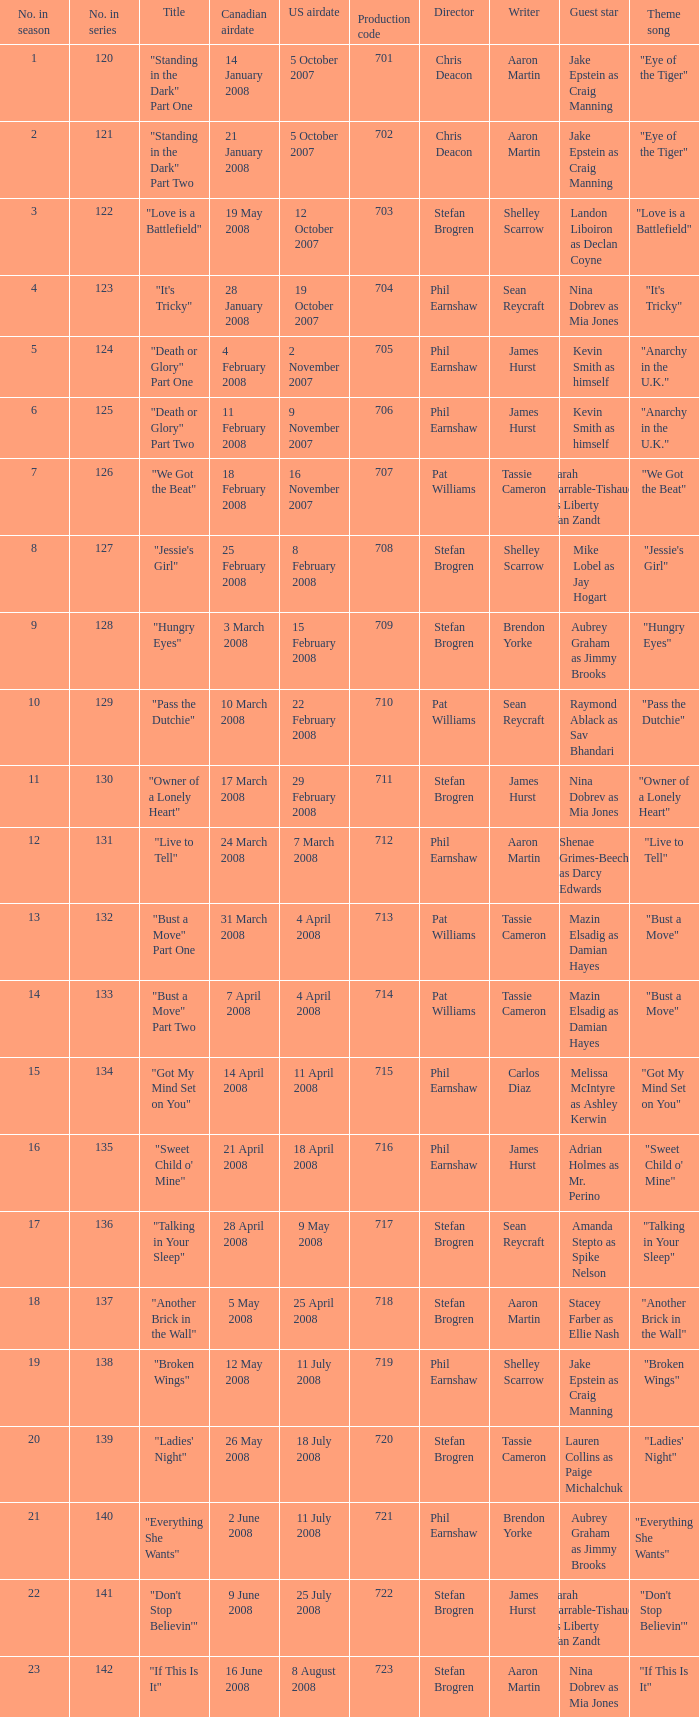The canadian airdate of 11 february 2008 applied to what series number? 1.0. 